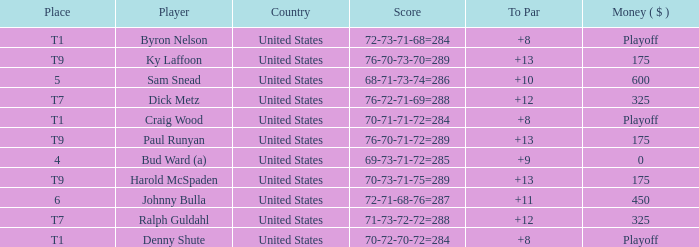What's the cash prize sam snead received? 600.0. 